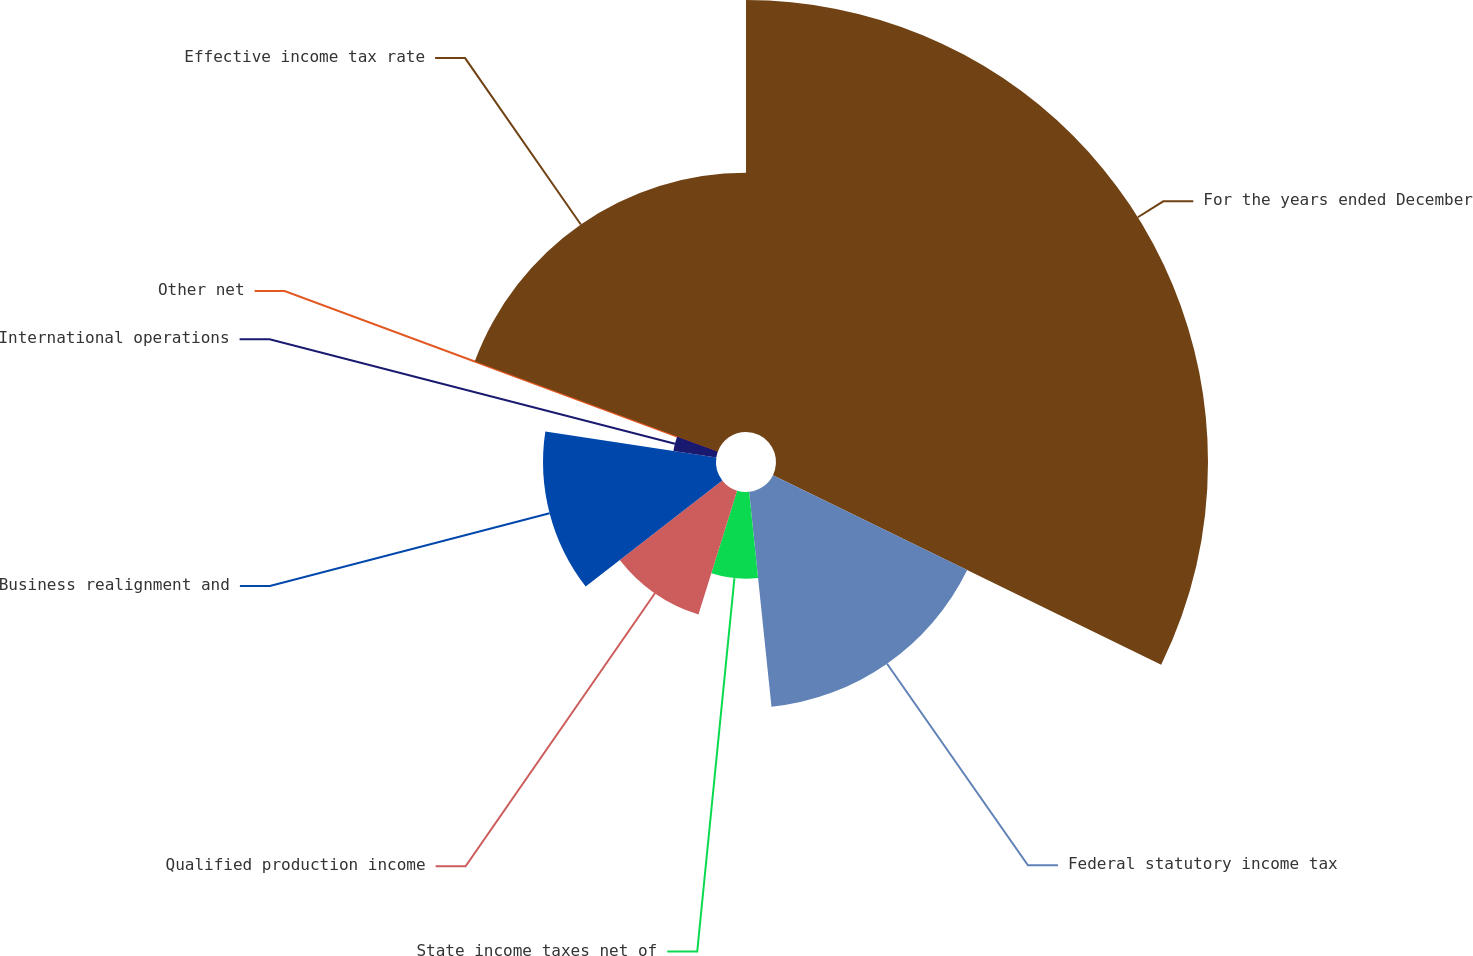Convert chart to OTSL. <chart><loc_0><loc_0><loc_500><loc_500><pie_chart><fcel>For the years ended December<fcel>Federal statutory income tax<fcel>State income taxes net of<fcel>Qualified production income<fcel>Business realignment and<fcel>International operations<fcel>Other net<fcel>Effective income tax rate<nl><fcel>32.22%<fcel>16.12%<fcel>6.46%<fcel>9.68%<fcel>12.9%<fcel>3.24%<fcel>0.02%<fcel>19.34%<nl></chart> 